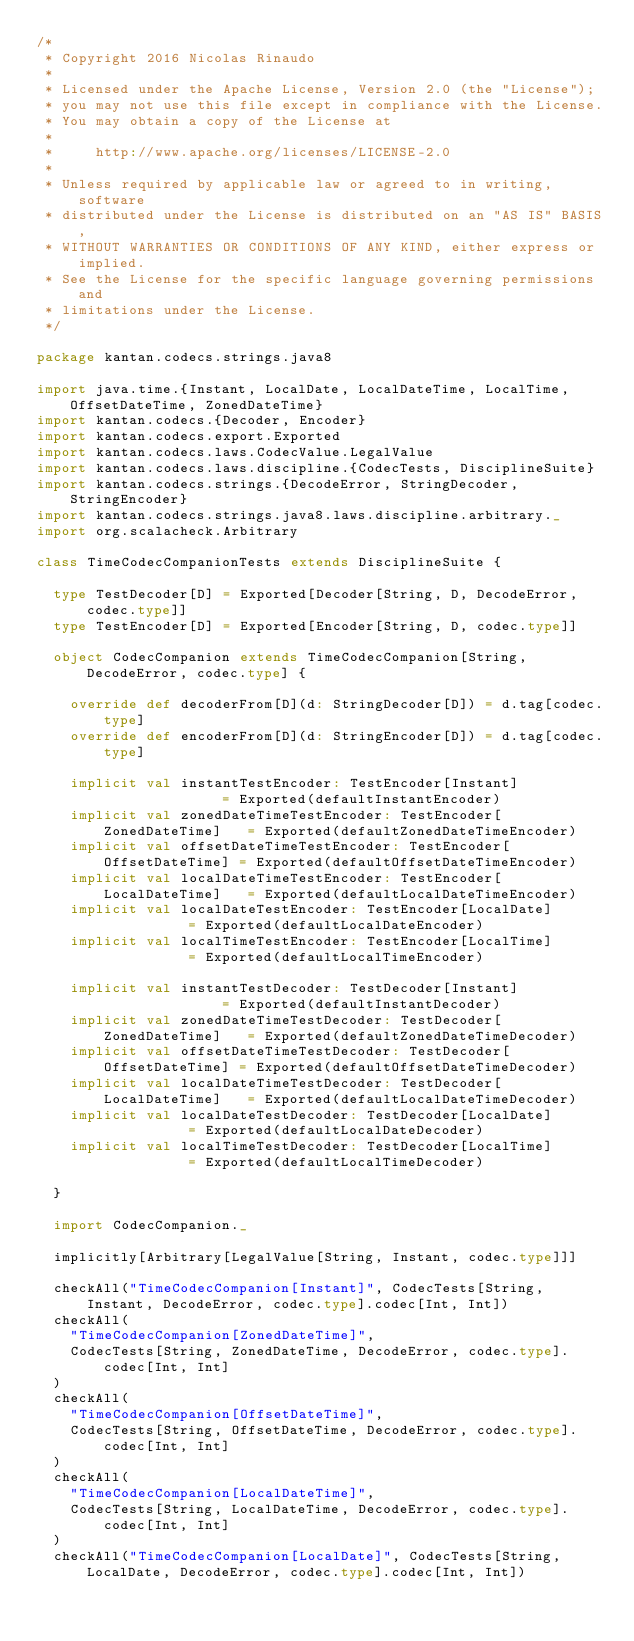<code> <loc_0><loc_0><loc_500><loc_500><_Scala_>/*
 * Copyright 2016 Nicolas Rinaudo
 *
 * Licensed under the Apache License, Version 2.0 (the "License");
 * you may not use this file except in compliance with the License.
 * You may obtain a copy of the License at
 *
 *     http://www.apache.org/licenses/LICENSE-2.0
 *
 * Unless required by applicable law or agreed to in writing, software
 * distributed under the License is distributed on an "AS IS" BASIS,
 * WITHOUT WARRANTIES OR CONDITIONS OF ANY KIND, either express or implied.
 * See the License for the specific language governing permissions and
 * limitations under the License.
 */

package kantan.codecs.strings.java8

import java.time.{Instant, LocalDate, LocalDateTime, LocalTime, OffsetDateTime, ZonedDateTime}
import kantan.codecs.{Decoder, Encoder}
import kantan.codecs.export.Exported
import kantan.codecs.laws.CodecValue.LegalValue
import kantan.codecs.laws.discipline.{CodecTests, DisciplineSuite}
import kantan.codecs.strings.{DecodeError, StringDecoder, StringEncoder}
import kantan.codecs.strings.java8.laws.discipline.arbitrary._
import org.scalacheck.Arbitrary

class TimeCodecCompanionTests extends DisciplineSuite {

  type TestDecoder[D] = Exported[Decoder[String, D, DecodeError, codec.type]]
  type TestEncoder[D] = Exported[Encoder[String, D, codec.type]]

  object CodecCompanion extends TimeCodecCompanion[String, DecodeError, codec.type] {

    override def decoderFrom[D](d: StringDecoder[D]) = d.tag[codec.type]
    override def encoderFrom[D](d: StringEncoder[D]) = d.tag[codec.type]

    implicit val instantTestEncoder: TestEncoder[Instant]               = Exported(defaultInstantEncoder)
    implicit val zonedDateTimeTestEncoder: TestEncoder[ZonedDateTime]   = Exported(defaultZonedDateTimeEncoder)
    implicit val offsetDateTimeTestEncoder: TestEncoder[OffsetDateTime] = Exported(defaultOffsetDateTimeEncoder)
    implicit val localDateTimeTestEncoder: TestEncoder[LocalDateTime]   = Exported(defaultLocalDateTimeEncoder)
    implicit val localDateTestEncoder: TestEncoder[LocalDate]           = Exported(defaultLocalDateEncoder)
    implicit val localTimeTestEncoder: TestEncoder[LocalTime]           = Exported(defaultLocalTimeEncoder)

    implicit val instantTestDecoder: TestDecoder[Instant]               = Exported(defaultInstantDecoder)
    implicit val zonedDateTimeTestDecoder: TestDecoder[ZonedDateTime]   = Exported(defaultZonedDateTimeDecoder)
    implicit val offsetDateTimeTestDecoder: TestDecoder[OffsetDateTime] = Exported(defaultOffsetDateTimeDecoder)
    implicit val localDateTimeTestDecoder: TestDecoder[LocalDateTime]   = Exported(defaultLocalDateTimeDecoder)
    implicit val localDateTestDecoder: TestDecoder[LocalDate]           = Exported(defaultLocalDateDecoder)
    implicit val localTimeTestDecoder: TestDecoder[LocalTime]           = Exported(defaultLocalTimeDecoder)

  }

  import CodecCompanion._

  implicitly[Arbitrary[LegalValue[String, Instant, codec.type]]]

  checkAll("TimeCodecCompanion[Instant]", CodecTests[String, Instant, DecodeError, codec.type].codec[Int, Int])
  checkAll(
    "TimeCodecCompanion[ZonedDateTime]",
    CodecTests[String, ZonedDateTime, DecodeError, codec.type].codec[Int, Int]
  )
  checkAll(
    "TimeCodecCompanion[OffsetDateTime]",
    CodecTests[String, OffsetDateTime, DecodeError, codec.type].codec[Int, Int]
  )
  checkAll(
    "TimeCodecCompanion[LocalDateTime]",
    CodecTests[String, LocalDateTime, DecodeError, codec.type].codec[Int, Int]
  )
  checkAll("TimeCodecCompanion[LocalDate]", CodecTests[String, LocalDate, DecodeError, codec.type].codec[Int, Int])</code> 